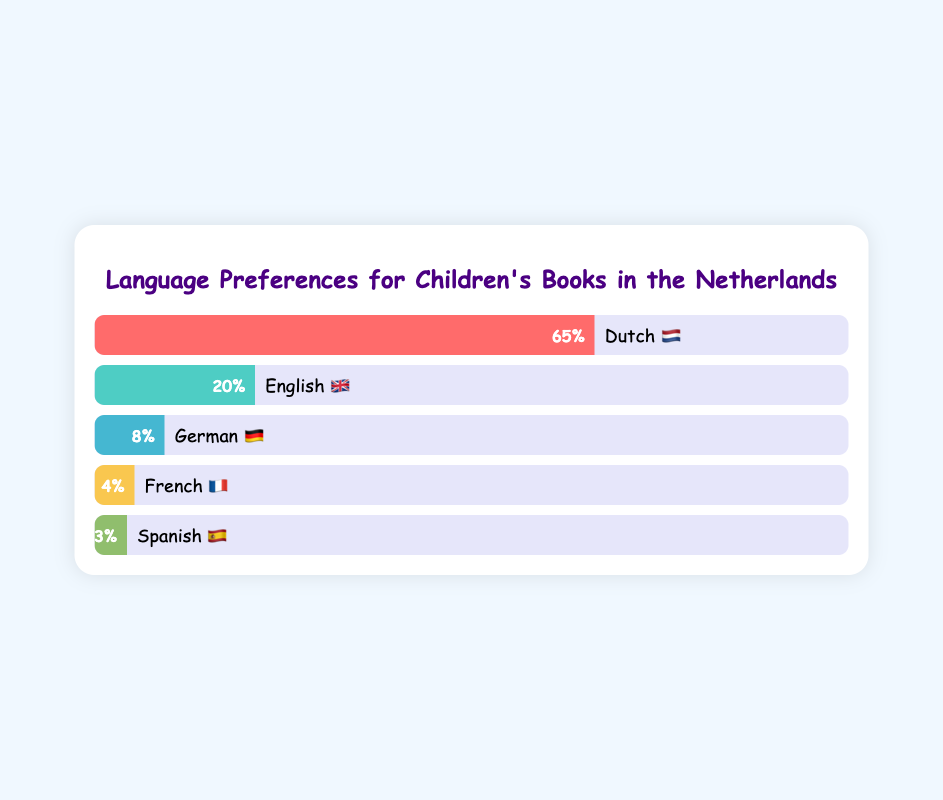Which language has the highest preference for children's books in the Netherlands? The bar representing "Dutch 🇳🇱" reaches the highest percentage at 65%, indicating it is the most preferred language.
Answer: Dutch 🇳🇱 What percentage of children's books are preferred in English 🇬🇧? The bar labeled "English 🇬🇧" shows a percentage of 20%.
Answer: 20% Which language has the lowest preference among the listed options? The "Spanish 🇪🇸" bar indicates the lowest percentage at 3%.
Answer: Spanish 🇪🇸 How much higher is the preference for Dutch 🇳🇱 books compared to German 🇩🇪 books? The preference for Dutch 🇳🇱 is 65%, and for German 🇩🇪 it is 8%. The difference is 65% - 8% = 57%.
Answer: 57% What is the combined percentage preference for French 🇫🇷 and Spanish 🇪🇸 children's books? French 🇫🇷 has 4% and Spanish 🇪🇸 has 3%. Adding them together gives 4% + 3% = 7%.
Answer: 7% How many languages are listed in the chart? There are five bars, each representing a different language.
Answer: 5 What is the average percentage preference for English 🇬🇧 and German 🇩🇪 books? English 🇬🇧 has 20% and German 🇩🇪 has 8%. The average is (20% + 8%) / 2 = 14%.
Answer: 14% By how much does the preference for Dutch 🇳🇱 books exceed the combined preference for French 🇫🇷 and Spanish 🇪🇸 books? Dutch 🇳🇱 has 65%, and the combined preference for French 🇫🇷 and Spanish 🇪🇸 is 7%. The excess is 65% - 7% = 58%.
Answer: 58% Which non-Dutch language has the highest preference for children's books? The bar representing "English 🇬🇧" at 20% is the highest among non-Dutch languages.
Answer: English 🇬🇧 